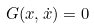<formula> <loc_0><loc_0><loc_500><loc_500>G ( x , \dot { x } ) = 0</formula> 